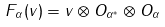Convert formula to latex. <formula><loc_0><loc_0><loc_500><loc_500>F _ { \alpha } ( v ) = v \otimes O _ { \alpha ^ { * } } \otimes O _ { \alpha } \\</formula> 